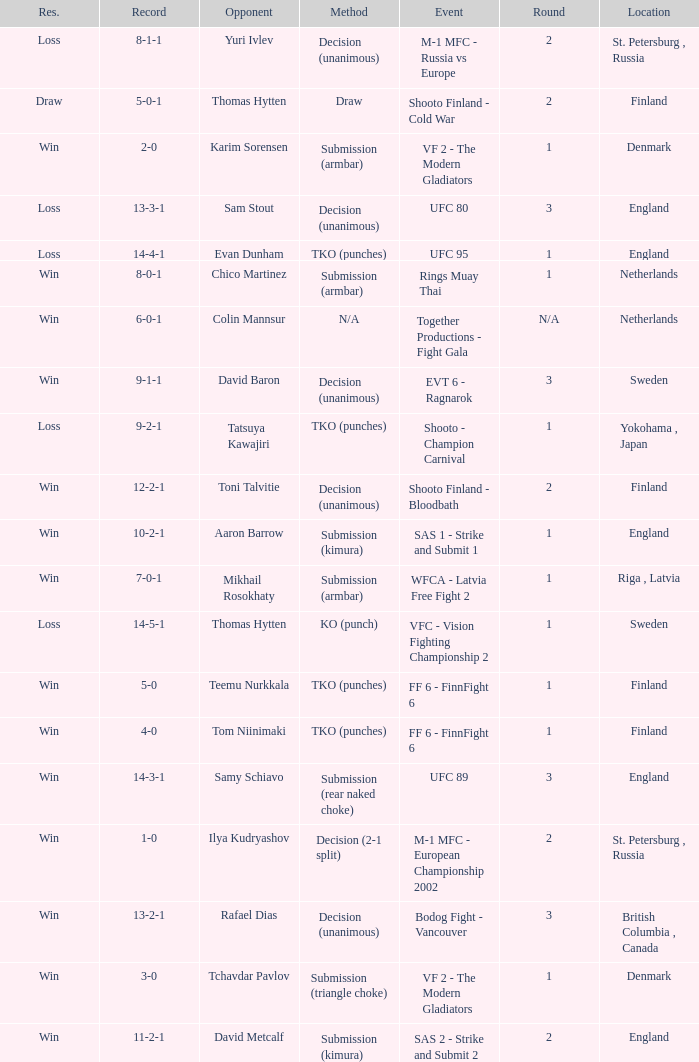What is the round in Finland with a draw for method? 2.0. Parse the table in full. {'header': ['Res.', 'Record', 'Opponent', 'Method', 'Event', 'Round', 'Location'], 'rows': [['Loss', '8-1-1', 'Yuri Ivlev', 'Decision (unanimous)', 'M-1 MFC - Russia vs Europe', '2', 'St. Petersburg , Russia'], ['Draw', '5-0-1', 'Thomas Hytten', 'Draw', 'Shooto Finland - Cold War', '2', 'Finland'], ['Win', '2-0', 'Karim Sorensen', 'Submission (armbar)', 'VF 2 - The Modern Gladiators', '1', 'Denmark'], ['Loss', '13-3-1', 'Sam Stout', 'Decision (unanimous)', 'UFC 80', '3', 'England'], ['Loss', '14-4-1', 'Evan Dunham', 'TKO (punches)', 'UFC 95', '1', 'England'], ['Win', '8-0-1', 'Chico Martinez', 'Submission (armbar)', 'Rings Muay Thai', '1', 'Netherlands'], ['Win', '6-0-1', 'Colin Mannsur', 'N/A', 'Together Productions - Fight Gala', 'N/A', 'Netherlands'], ['Win', '9-1-1', 'David Baron', 'Decision (unanimous)', 'EVT 6 - Ragnarok', '3', 'Sweden'], ['Loss', '9-2-1', 'Tatsuya Kawajiri', 'TKO (punches)', 'Shooto - Champion Carnival', '1', 'Yokohama , Japan'], ['Win', '12-2-1', 'Toni Talvitie', 'Decision (unanimous)', 'Shooto Finland - Bloodbath', '2', 'Finland'], ['Win', '10-2-1', 'Aaron Barrow', 'Submission (kimura)', 'SAS 1 - Strike and Submit 1', '1', 'England'], ['Win', '7-0-1', 'Mikhail Rosokhaty', 'Submission (armbar)', 'WFCA - Latvia Free Fight 2', '1', 'Riga , Latvia'], ['Loss', '14-5-1', 'Thomas Hytten', 'KO (punch)', 'VFC - Vision Fighting Championship 2', '1', 'Sweden'], ['Win', '5-0', 'Teemu Nurkkala', 'TKO (punches)', 'FF 6 - FinnFight 6', '1', 'Finland'], ['Win', '4-0', 'Tom Niinimaki', 'TKO (punches)', 'FF 6 - FinnFight 6', '1', 'Finland'], ['Win', '14-3-1', 'Samy Schiavo', 'Submission (rear naked choke)', 'UFC 89', '3', 'England'], ['Win', '1-0', 'Ilya Kudryashov', 'Decision (2-1 split)', 'M-1 MFC - European Championship 2002', '2', 'St. Petersburg , Russia'], ['Win', '13-2-1', 'Rafael Dias', 'Decision (unanimous)', 'Bodog Fight - Vancouver', '3', 'British Columbia , Canada'], ['Win', '3-0', 'Tchavdar Pavlov', 'Submission (triangle choke)', 'VF 2 - The Modern Gladiators', '1', 'Denmark'], ['Win', '11-2-1', 'David Metcalf', 'Submission (kimura)', 'SAS 2 - Strike and Submit 2', '2', 'England']]} 